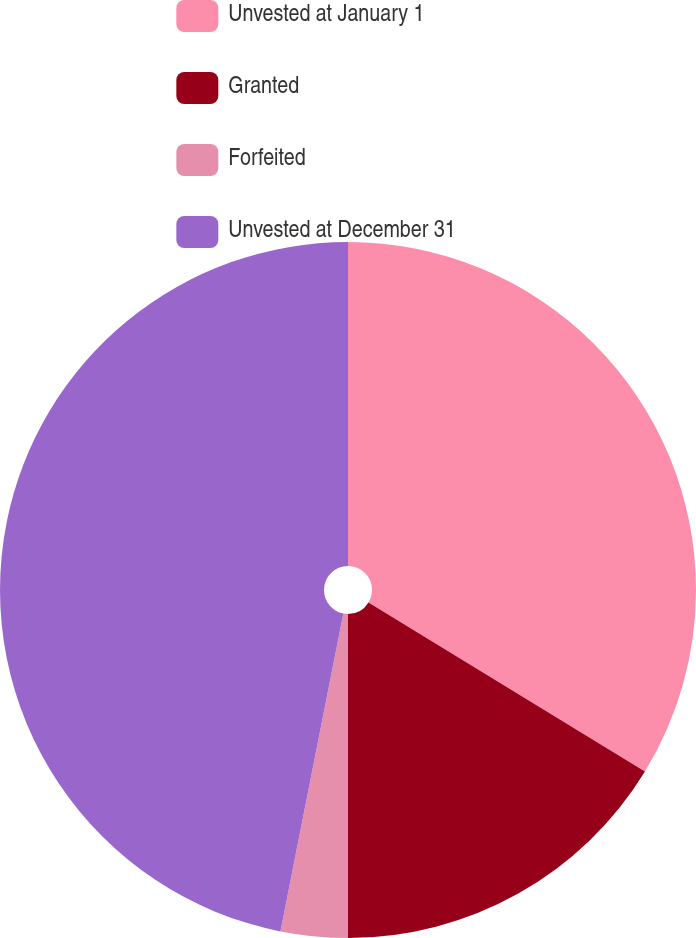<chart> <loc_0><loc_0><loc_500><loc_500><pie_chart><fcel>Unvested at January 1<fcel>Granted<fcel>Forfeited<fcel>Unvested at December 31<nl><fcel>33.73%<fcel>16.27%<fcel>3.11%<fcel>46.89%<nl></chart> 